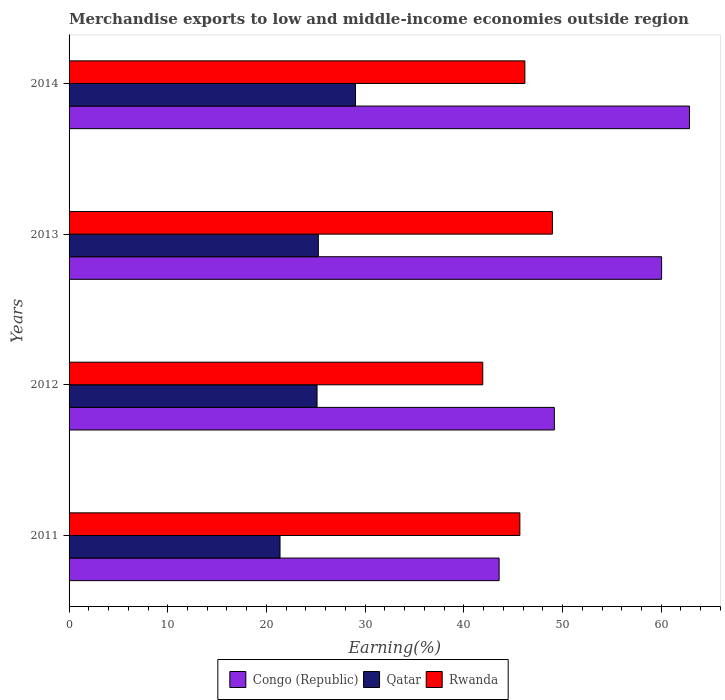How many groups of bars are there?
Your response must be concise. 4. Are the number of bars per tick equal to the number of legend labels?
Your answer should be compact. Yes. Are the number of bars on each tick of the Y-axis equal?
Give a very brief answer. Yes. How many bars are there on the 2nd tick from the bottom?
Keep it short and to the point. 3. In how many cases, is the number of bars for a given year not equal to the number of legend labels?
Keep it short and to the point. 0. What is the percentage of amount earned from merchandise exports in Qatar in 2013?
Give a very brief answer. 25.26. Across all years, what is the maximum percentage of amount earned from merchandise exports in Rwanda?
Ensure brevity in your answer.  48.98. Across all years, what is the minimum percentage of amount earned from merchandise exports in Congo (Republic)?
Offer a very short reply. 43.58. In which year was the percentage of amount earned from merchandise exports in Congo (Republic) minimum?
Provide a succinct answer. 2011. What is the total percentage of amount earned from merchandise exports in Qatar in the graph?
Offer a terse response. 100.78. What is the difference between the percentage of amount earned from merchandise exports in Congo (Republic) in 2011 and that in 2013?
Make the answer very short. -16.46. What is the difference between the percentage of amount earned from merchandise exports in Qatar in 2014 and the percentage of amount earned from merchandise exports in Rwanda in 2013?
Offer a very short reply. -19.95. What is the average percentage of amount earned from merchandise exports in Qatar per year?
Provide a short and direct response. 25.2. In the year 2011, what is the difference between the percentage of amount earned from merchandise exports in Rwanda and percentage of amount earned from merchandise exports in Congo (Republic)?
Ensure brevity in your answer.  2.1. In how many years, is the percentage of amount earned from merchandise exports in Congo (Republic) greater than 8 %?
Offer a very short reply. 4. What is the ratio of the percentage of amount earned from merchandise exports in Qatar in 2012 to that in 2013?
Offer a terse response. 0.99. What is the difference between the highest and the second highest percentage of amount earned from merchandise exports in Qatar?
Provide a short and direct response. 3.76. What is the difference between the highest and the lowest percentage of amount earned from merchandise exports in Congo (Republic)?
Give a very brief answer. 19.29. Is the sum of the percentage of amount earned from merchandise exports in Rwanda in 2012 and 2014 greater than the maximum percentage of amount earned from merchandise exports in Qatar across all years?
Give a very brief answer. Yes. What does the 3rd bar from the top in 2011 represents?
Give a very brief answer. Congo (Republic). What does the 3rd bar from the bottom in 2013 represents?
Offer a terse response. Rwanda. Is it the case that in every year, the sum of the percentage of amount earned from merchandise exports in Rwanda and percentage of amount earned from merchandise exports in Congo (Republic) is greater than the percentage of amount earned from merchandise exports in Qatar?
Give a very brief answer. Yes. How many years are there in the graph?
Your answer should be compact. 4. Where does the legend appear in the graph?
Your answer should be very brief. Bottom center. How many legend labels are there?
Provide a succinct answer. 3. What is the title of the graph?
Ensure brevity in your answer.  Merchandise exports to low and middle-income economies outside region. Does "Northern Mariana Islands" appear as one of the legend labels in the graph?
Keep it short and to the point. No. What is the label or title of the X-axis?
Your answer should be compact. Earning(%). What is the label or title of the Y-axis?
Your answer should be compact. Years. What is the Earning(%) of Congo (Republic) in 2011?
Keep it short and to the point. 43.58. What is the Earning(%) in Qatar in 2011?
Offer a very short reply. 21.38. What is the Earning(%) of Rwanda in 2011?
Give a very brief answer. 45.68. What is the Earning(%) in Congo (Republic) in 2012?
Make the answer very short. 49.17. What is the Earning(%) of Qatar in 2012?
Make the answer very short. 25.13. What is the Earning(%) in Rwanda in 2012?
Your answer should be very brief. 41.92. What is the Earning(%) in Congo (Republic) in 2013?
Provide a succinct answer. 60.04. What is the Earning(%) of Qatar in 2013?
Make the answer very short. 25.26. What is the Earning(%) in Rwanda in 2013?
Make the answer very short. 48.98. What is the Earning(%) in Congo (Republic) in 2014?
Your answer should be compact. 62.86. What is the Earning(%) in Qatar in 2014?
Give a very brief answer. 29.02. What is the Earning(%) in Rwanda in 2014?
Provide a succinct answer. 46.18. Across all years, what is the maximum Earning(%) in Congo (Republic)?
Offer a terse response. 62.86. Across all years, what is the maximum Earning(%) in Qatar?
Provide a succinct answer. 29.02. Across all years, what is the maximum Earning(%) of Rwanda?
Your answer should be very brief. 48.98. Across all years, what is the minimum Earning(%) in Congo (Republic)?
Your response must be concise. 43.58. Across all years, what is the minimum Earning(%) in Qatar?
Your answer should be compact. 21.38. Across all years, what is the minimum Earning(%) in Rwanda?
Provide a short and direct response. 41.92. What is the total Earning(%) in Congo (Republic) in the graph?
Make the answer very short. 215.65. What is the total Earning(%) in Qatar in the graph?
Ensure brevity in your answer.  100.78. What is the total Earning(%) in Rwanda in the graph?
Keep it short and to the point. 182.76. What is the difference between the Earning(%) of Congo (Republic) in 2011 and that in 2012?
Ensure brevity in your answer.  -5.6. What is the difference between the Earning(%) of Qatar in 2011 and that in 2012?
Give a very brief answer. -3.75. What is the difference between the Earning(%) of Rwanda in 2011 and that in 2012?
Give a very brief answer. 3.76. What is the difference between the Earning(%) of Congo (Republic) in 2011 and that in 2013?
Keep it short and to the point. -16.46. What is the difference between the Earning(%) of Qatar in 2011 and that in 2013?
Ensure brevity in your answer.  -3.88. What is the difference between the Earning(%) of Rwanda in 2011 and that in 2013?
Offer a very short reply. -3.3. What is the difference between the Earning(%) in Congo (Republic) in 2011 and that in 2014?
Provide a succinct answer. -19.29. What is the difference between the Earning(%) in Qatar in 2011 and that in 2014?
Provide a short and direct response. -7.65. What is the difference between the Earning(%) of Rwanda in 2011 and that in 2014?
Give a very brief answer. -0.51. What is the difference between the Earning(%) of Congo (Republic) in 2012 and that in 2013?
Your answer should be very brief. -10.87. What is the difference between the Earning(%) in Qatar in 2012 and that in 2013?
Make the answer very short. -0.13. What is the difference between the Earning(%) of Rwanda in 2012 and that in 2013?
Your answer should be compact. -7.06. What is the difference between the Earning(%) of Congo (Republic) in 2012 and that in 2014?
Your answer should be compact. -13.69. What is the difference between the Earning(%) in Qatar in 2012 and that in 2014?
Give a very brief answer. -3.9. What is the difference between the Earning(%) of Rwanda in 2012 and that in 2014?
Your answer should be compact. -4.27. What is the difference between the Earning(%) in Congo (Republic) in 2013 and that in 2014?
Offer a terse response. -2.82. What is the difference between the Earning(%) in Qatar in 2013 and that in 2014?
Your answer should be very brief. -3.76. What is the difference between the Earning(%) in Rwanda in 2013 and that in 2014?
Provide a succinct answer. 2.79. What is the difference between the Earning(%) of Congo (Republic) in 2011 and the Earning(%) of Qatar in 2012?
Provide a short and direct response. 18.45. What is the difference between the Earning(%) of Congo (Republic) in 2011 and the Earning(%) of Rwanda in 2012?
Your answer should be very brief. 1.66. What is the difference between the Earning(%) in Qatar in 2011 and the Earning(%) in Rwanda in 2012?
Your answer should be very brief. -20.54. What is the difference between the Earning(%) of Congo (Republic) in 2011 and the Earning(%) of Qatar in 2013?
Your answer should be very brief. 18.32. What is the difference between the Earning(%) in Congo (Republic) in 2011 and the Earning(%) in Rwanda in 2013?
Keep it short and to the point. -5.4. What is the difference between the Earning(%) in Qatar in 2011 and the Earning(%) in Rwanda in 2013?
Give a very brief answer. -27.6. What is the difference between the Earning(%) in Congo (Republic) in 2011 and the Earning(%) in Qatar in 2014?
Make the answer very short. 14.55. What is the difference between the Earning(%) of Congo (Republic) in 2011 and the Earning(%) of Rwanda in 2014?
Your answer should be compact. -2.61. What is the difference between the Earning(%) in Qatar in 2011 and the Earning(%) in Rwanda in 2014?
Keep it short and to the point. -24.81. What is the difference between the Earning(%) of Congo (Republic) in 2012 and the Earning(%) of Qatar in 2013?
Provide a succinct answer. 23.91. What is the difference between the Earning(%) of Congo (Republic) in 2012 and the Earning(%) of Rwanda in 2013?
Give a very brief answer. 0.19. What is the difference between the Earning(%) in Qatar in 2012 and the Earning(%) in Rwanda in 2013?
Your answer should be very brief. -23.85. What is the difference between the Earning(%) in Congo (Republic) in 2012 and the Earning(%) in Qatar in 2014?
Provide a succinct answer. 20.15. What is the difference between the Earning(%) in Congo (Republic) in 2012 and the Earning(%) in Rwanda in 2014?
Give a very brief answer. 2.99. What is the difference between the Earning(%) of Qatar in 2012 and the Earning(%) of Rwanda in 2014?
Your answer should be very brief. -21.06. What is the difference between the Earning(%) in Congo (Republic) in 2013 and the Earning(%) in Qatar in 2014?
Give a very brief answer. 31.02. What is the difference between the Earning(%) in Congo (Republic) in 2013 and the Earning(%) in Rwanda in 2014?
Your response must be concise. 13.86. What is the difference between the Earning(%) in Qatar in 2013 and the Earning(%) in Rwanda in 2014?
Your response must be concise. -20.93. What is the average Earning(%) of Congo (Republic) per year?
Offer a terse response. 53.91. What is the average Earning(%) in Qatar per year?
Ensure brevity in your answer.  25.2. What is the average Earning(%) of Rwanda per year?
Offer a terse response. 45.69. In the year 2011, what is the difference between the Earning(%) in Congo (Republic) and Earning(%) in Qatar?
Offer a very short reply. 22.2. In the year 2011, what is the difference between the Earning(%) in Congo (Republic) and Earning(%) in Rwanda?
Ensure brevity in your answer.  -2.1. In the year 2011, what is the difference between the Earning(%) of Qatar and Earning(%) of Rwanda?
Keep it short and to the point. -24.3. In the year 2012, what is the difference between the Earning(%) of Congo (Republic) and Earning(%) of Qatar?
Keep it short and to the point. 24.04. In the year 2012, what is the difference between the Earning(%) of Congo (Republic) and Earning(%) of Rwanda?
Your answer should be compact. 7.25. In the year 2012, what is the difference between the Earning(%) in Qatar and Earning(%) in Rwanda?
Offer a very short reply. -16.79. In the year 2013, what is the difference between the Earning(%) in Congo (Republic) and Earning(%) in Qatar?
Provide a succinct answer. 34.78. In the year 2013, what is the difference between the Earning(%) in Congo (Republic) and Earning(%) in Rwanda?
Your answer should be compact. 11.06. In the year 2013, what is the difference between the Earning(%) of Qatar and Earning(%) of Rwanda?
Give a very brief answer. -23.72. In the year 2014, what is the difference between the Earning(%) of Congo (Republic) and Earning(%) of Qatar?
Give a very brief answer. 33.84. In the year 2014, what is the difference between the Earning(%) in Congo (Republic) and Earning(%) in Rwanda?
Offer a very short reply. 16.68. In the year 2014, what is the difference between the Earning(%) in Qatar and Earning(%) in Rwanda?
Provide a short and direct response. -17.16. What is the ratio of the Earning(%) of Congo (Republic) in 2011 to that in 2012?
Your answer should be very brief. 0.89. What is the ratio of the Earning(%) in Qatar in 2011 to that in 2012?
Give a very brief answer. 0.85. What is the ratio of the Earning(%) of Rwanda in 2011 to that in 2012?
Provide a short and direct response. 1.09. What is the ratio of the Earning(%) of Congo (Republic) in 2011 to that in 2013?
Provide a succinct answer. 0.73. What is the ratio of the Earning(%) in Qatar in 2011 to that in 2013?
Ensure brevity in your answer.  0.85. What is the ratio of the Earning(%) of Rwanda in 2011 to that in 2013?
Offer a terse response. 0.93. What is the ratio of the Earning(%) in Congo (Republic) in 2011 to that in 2014?
Your response must be concise. 0.69. What is the ratio of the Earning(%) in Qatar in 2011 to that in 2014?
Provide a succinct answer. 0.74. What is the ratio of the Earning(%) in Congo (Republic) in 2012 to that in 2013?
Ensure brevity in your answer.  0.82. What is the ratio of the Earning(%) of Rwanda in 2012 to that in 2013?
Offer a terse response. 0.86. What is the ratio of the Earning(%) of Congo (Republic) in 2012 to that in 2014?
Your answer should be very brief. 0.78. What is the ratio of the Earning(%) of Qatar in 2012 to that in 2014?
Your answer should be compact. 0.87. What is the ratio of the Earning(%) in Rwanda in 2012 to that in 2014?
Your answer should be very brief. 0.91. What is the ratio of the Earning(%) in Congo (Republic) in 2013 to that in 2014?
Your answer should be compact. 0.96. What is the ratio of the Earning(%) in Qatar in 2013 to that in 2014?
Make the answer very short. 0.87. What is the ratio of the Earning(%) of Rwanda in 2013 to that in 2014?
Provide a succinct answer. 1.06. What is the difference between the highest and the second highest Earning(%) of Congo (Republic)?
Make the answer very short. 2.82. What is the difference between the highest and the second highest Earning(%) in Qatar?
Your answer should be compact. 3.76. What is the difference between the highest and the second highest Earning(%) of Rwanda?
Ensure brevity in your answer.  2.79. What is the difference between the highest and the lowest Earning(%) in Congo (Republic)?
Offer a very short reply. 19.29. What is the difference between the highest and the lowest Earning(%) of Qatar?
Provide a short and direct response. 7.65. What is the difference between the highest and the lowest Earning(%) in Rwanda?
Your response must be concise. 7.06. 